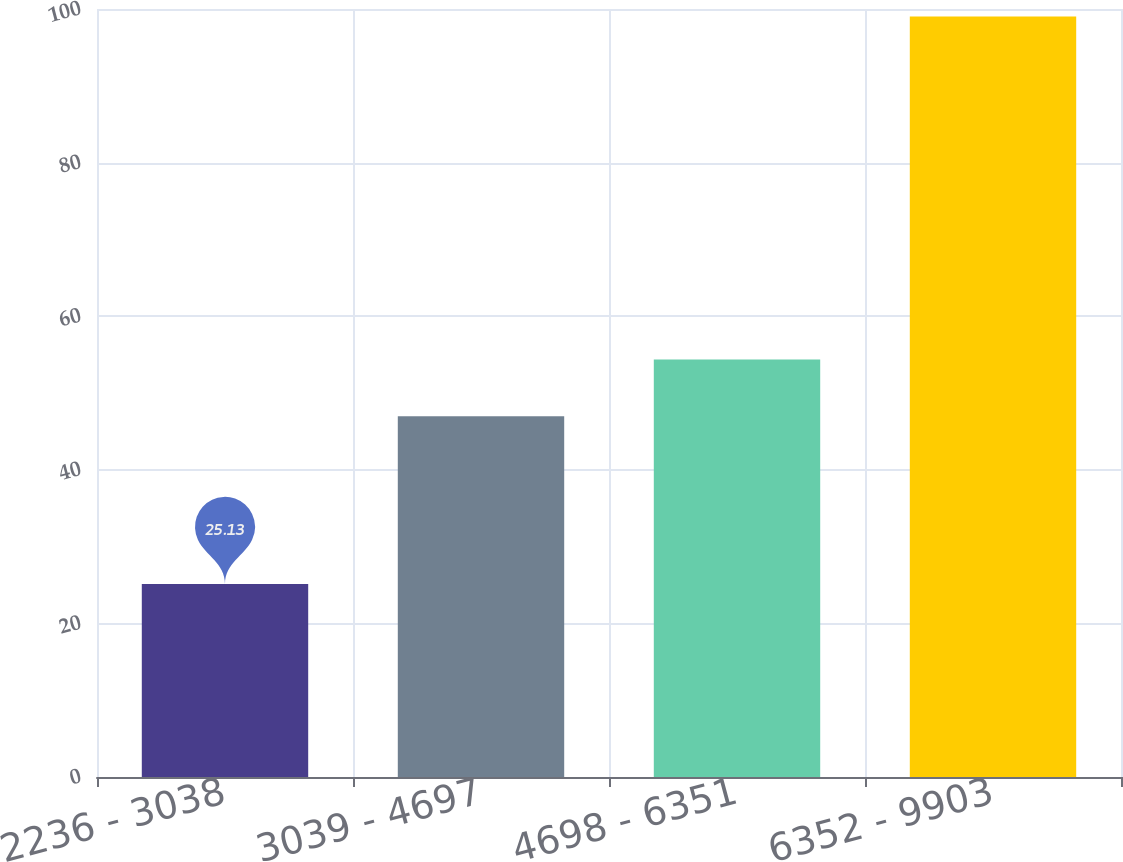<chart> <loc_0><loc_0><loc_500><loc_500><bar_chart><fcel>2236 - 3038<fcel>3039 - 4697<fcel>4698 - 6351<fcel>6352 - 9903<nl><fcel>25.13<fcel>46.97<fcel>54.36<fcel>99.03<nl></chart> 